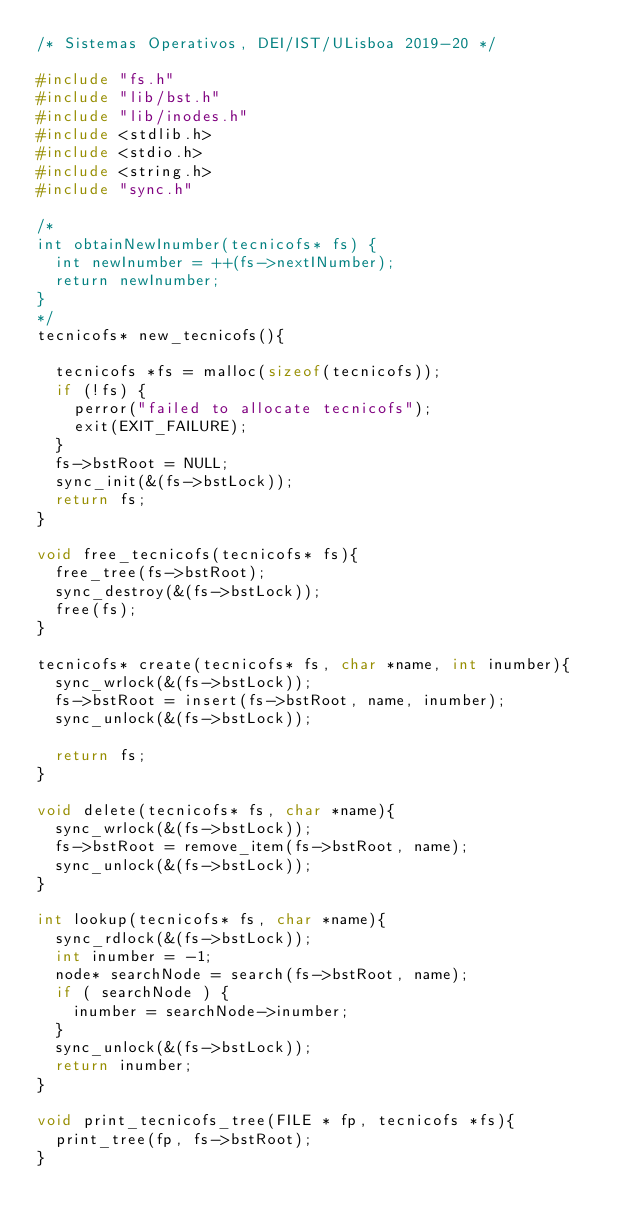Convert code to text. <code><loc_0><loc_0><loc_500><loc_500><_C_>/* Sistemas Operativos, DEI/IST/ULisboa 2019-20 */

#include "fs.h"
#include "lib/bst.h"
#include "lib/inodes.h"
#include <stdlib.h>
#include <stdio.h>
#include <string.h>
#include "sync.h"

/*
int obtainNewInumber(tecnicofs* fs) {
	int newInumber = ++(fs->nextINumber);
	return newInumber;
}
*/
tecnicofs* new_tecnicofs(){

	tecnicofs *fs = malloc(sizeof(tecnicofs));
	if (!fs) {
		perror("failed to allocate tecnicofs");
		exit(EXIT_FAILURE);
	}
	fs->bstRoot = NULL;
	sync_init(&(fs->bstLock));
	return fs;
}

void free_tecnicofs(tecnicofs* fs){
	free_tree(fs->bstRoot);
	sync_destroy(&(fs->bstLock));
	free(fs);
}

tecnicofs* create(tecnicofs* fs, char *name, int inumber){
	sync_wrlock(&(fs->bstLock));
	fs->bstRoot = insert(fs->bstRoot, name, inumber);
	sync_unlock(&(fs->bstLock));

	return fs;
}

void delete(tecnicofs* fs, char *name){
	sync_wrlock(&(fs->bstLock));
	fs->bstRoot = remove_item(fs->bstRoot, name);
	sync_unlock(&(fs->bstLock));
}

int lookup(tecnicofs* fs, char *name){
	sync_rdlock(&(fs->bstLock));
	int inumber = -1;
	node* searchNode = search(fs->bstRoot, name);
	if ( searchNode ) {
		inumber = searchNode->inumber;
	}
	sync_unlock(&(fs->bstLock));
	return inumber;
}

void print_tecnicofs_tree(FILE * fp, tecnicofs *fs){
	print_tree(fp, fs->bstRoot);
}
</code> 